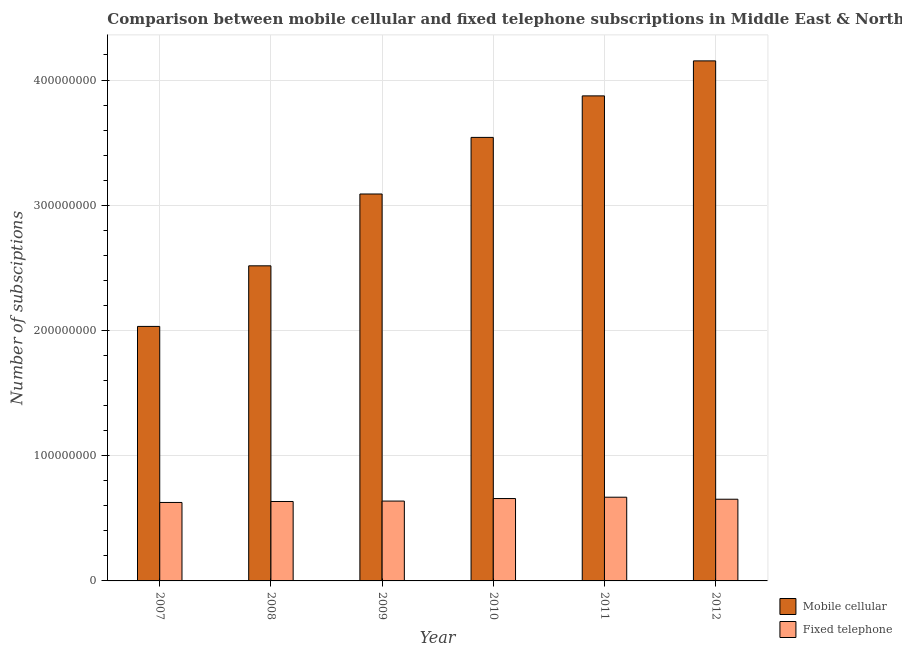Are the number of bars per tick equal to the number of legend labels?
Your response must be concise. Yes. Are the number of bars on each tick of the X-axis equal?
Your answer should be compact. Yes. How many bars are there on the 6th tick from the right?
Give a very brief answer. 2. What is the label of the 1st group of bars from the left?
Your answer should be very brief. 2007. What is the number of mobile cellular subscriptions in 2009?
Your answer should be compact. 3.09e+08. Across all years, what is the maximum number of mobile cellular subscriptions?
Offer a terse response. 4.15e+08. Across all years, what is the minimum number of fixed telephone subscriptions?
Make the answer very short. 6.27e+07. In which year was the number of fixed telephone subscriptions minimum?
Provide a succinct answer. 2007. What is the total number of fixed telephone subscriptions in the graph?
Offer a very short reply. 3.88e+08. What is the difference between the number of mobile cellular subscriptions in 2009 and that in 2010?
Your answer should be compact. -4.52e+07. What is the difference between the number of fixed telephone subscriptions in 2010 and the number of mobile cellular subscriptions in 2009?
Offer a terse response. 2.02e+06. What is the average number of fixed telephone subscriptions per year?
Ensure brevity in your answer.  6.46e+07. What is the ratio of the number of fixed telephone subscriptions in 2008 to that in 2011?
Offer a terse response. 0.95. Is the number of mobile cellular subscriptions in 2007 less than that in 2008?
Provide a succinct answer. Yes. What is the difference between the highest and the second highest number of mobile cellular subscriptions?
Your answer should be very brief. 2.80e+07. What is the difference between the highest and the lowest number of mobile cellular subscriptions?
Provide a succinct answer. 2.12e+08. Is the sum of the number of fixed telephone subscriptions in 2009 and 2012 greater than the maximum number of mobile cellular subscriptions across all years?
Your answer should be very brief. Yes. What does the 1st bar from the left in 2012 represents?
Give a very brief answer. Mobile cellular. What does the 2nd bar from the right in 2012 represents?
Your answer should be very brief. Mobile cellular. Does the graph contain any zero values?
Keep it short and to the point. No. Does the graph contain grids?
Keep it short and to the point. Yes. Where does the legend appear in the graph?
Offer a very short reply. Bottom right. How many legend labels are there?
Your answer should be compact. 2. What is the title of the graph?
Your response must be concise. Comparison between mobile cellular and fixed telephone subscriptions in Middle East & North Africa (all income levels). Does "Imports" appear as one of the legend labels in the graph?
Ensure brevity in your answer.  No. What is the label or title of the Y-axis?
Ensure brevity in your answer.  Number of subsciptions. What is the Number of subsciptions of Mobile cellular in 2007?
Ensure brevity in your answer.  2.03e+08. What is the Number of subsciptions in Fixed telephone in 2007?
Make the answer very short. 6.27e+07. What is the Number of subsciptions of Mobile cellular in 2008?
Your answer should be very brief. 2.52e+08. What is the Number of subsciptions in Fixed telephone in 2008?
Ensure brevity in your answer.  6.34e+07. What is the Number of subsciptions in Mobile cellular in 2009?
Offer a very short reply. 3.09e+08. What is the Number of subsciptions in Fixed telephone in 2009?
Offer a terse response. 6.38e+07. What is the Number of subsciptions of Mobile cellular in 2010?
Your answer should be compact. 3.54e+08. What is the Number of subsciptions in Fixed telephone in 2010?
Your answer should be very brief. 6.58e+07. What is the Number of subsciptions of Mobile cellular in 2011?
Your answer should be very brief. 3.87e+08. What is the Number of subsciptions in Fixed telephone in 2011?
Provide a short and direct response. 6.68e+07. What is the Number of subsciptions in Mobile cellular in 2012?
Give a very brief answer. 4.15e+08. What is the Number of subsciptions in Fixed telephone in 2012?
Ensure brevity in your answer.  6.52e+07. Across all years, what is the maximum Number of subsciptions of Mobile cellular?
Offer a very short reply. 4.15e+08. Across all years, what is the maximum Number of subsciptions of Fixed telephone?
Your answer should be very brief. 6.68e+07. Across all years, what is the minimum Number of subsciptions in Mobile cellular?
Offer a very short reply. 2.03e+08. Across all years, what is the minimum Number of subsciptions in Fixed telephone?
Offer a terse response. 6.27e+07. What is the total Number of subsciptions of Mobile cellular in the graph?
Offer a terse response. 1.92e+09. What is the total Number of subsciptions of Fixed telephone in the graph?
Ensure brevity in your answer.  3.88e+08. What is the difference between the Number of subsciptions of Mobile cellular in 2007 and that in 2008?
Offer a terse response. -4.84e+07. What is the difference between the Number of subsciptions of Fixed telephone in 2007 and that in 2008?
Offer a terse response. -7.72e+05. What is the difference between the Number of subsciptions of Mobile cellular in 2007 and that in 2009?
Offer a very short reply. -1.06e+08. What is the difference between the Number of subsciptions of Fixed telephone in 2007 and that in 2009?
Your answer should be compact. -1.11e+06. What is the difference between the Number of subsciptions of Mobile cellular in 2007 and that in 2010?
Keep it short and to the point. -1.51e+08. What is the difference between the Number of subsciptions in Fixed telephone in 2007 and that in 2010?
Your answer should be very brief. -3.13e+06. What is the difference between the Number of subsciptions in Mobile cellular in 2007 and that in 2011?
Offer a terse response. -1.84e+08. What is the difference between the Number of subsciptions of Fixed telephone in 2007 and that in 2011?
Offer a terse response. -4.19e+06. What is the difference between the Number of subsciptions of Mobile cellular in 2007 and that in 2012?
Give a very brief answer. -2.12e+08. What is the difference between the Number of subsciptions in Fixed telephone in 2007 and that in 2012?
Your response must be concise. -2.59e+06. What is the difference between the Number of subsciptions in Mobile cellular in 2008 and that in 2009?
Give a very brief answer. -5.74e+07. What is the difference between the Number of subsciptions in Fixed telephone in 2008 and that in 2009?
Provide a succinct answer. -3.36e+05. What is the difference between the Number of subsciptions of Mobile cellular in 2008 and that in 2010?
Offer a very short reply. -1.03e+08. What is the difference between the Number of subsciptions in Fixed telephone in 2008 and that in 2010?
Offer a very short reply. -2.35e+06. What is the difference between the Number of subsciptions in Mobile cellular in 2008 and that in 2011?
Provide a short and direct response. -1.36e+08. What is the difference between the Number of subsciptions in Fixed telephone in 2008 and that in 2011?
Offer a terse response. -3.42e+06. What is the difference between the Number of subsciptions in Mobile cellular in 2008 and that in 2012?
Offer a terse response. -1.64e+08. What is the difference between the Number of subsciptions of Fixed telephone in 2008 and that in 2012?
Your answer should be very brief. -1.81e+06. What is the difference between the Number of subsciptions of Mobile cellular in 2009 and that in 2010?
Your answer should be compact. -4.52e+07. What is the difference between the Number of subsciptions of Fixed telephone in 2009 and that in 2010?
Provide a short and direct response. -2.02e+06. What is the difference between the Number of subsciptions of Mobile cellular in 2009 and that in 2011?
Keep it short and to the point. -7.84e+07. What is the difference between the Number of subsciptions of Fixed telephone in 2009 and that in 2011?
Your answer should be very brief. -3.08e+06. What is the difference between the Number of subsciptions of Mobile cellular in 2009 and that in 2012?
Your response must be concise. -1.06e+08. What is the difference between the Number of subsciptions of Fixed telephone in 2009 and that in 2012?
Ensure brevity in your answer.  -1.48e+06. What is the difference between the Number of subsciptions in Mobile cellular in 2010 and that in 2011?
Your answer should be compact. -3.32e+07. What is the difference between the Number of subsciptions of Fixed telephone in 2010 and that in 2011?
Ensure brevity in your answer.  -1.06e+06. What is the difference between the Number of subsciptions in Mobile cellular in 2010 and that in 2012?
Provide a short and direct response. -6.11e+07. What is the difference between the Number of subsciptions of Fixed telephone in 2010 and that in 2012?
Ensure brevity in your answer.  5.40e+05. What is the difference between the Number of subsciptions of Mobile cellular in 2011 and that in 2012?
Make the answer very short. -2.80e+07. What is the difference between the Number of subsciptions in Fixed telephone in 2011 and that in 2012?
Provide a short and direct response. 1.60e+06. What is the difference between the Number of subsciptions of Mobile cellular in 2007 and the Number of subsciptions of Fixed telephone in 2008?
Your response must be concise. 1.40e+08. What is the difference between the Number of subsciptions of Mobile cellular in 2007 and the Number of subsciptions of Fixed telephone in 2009?
Give a very brief answer. 1.39e+08. What is the difference between the Number of subsciptions of Mobile cellular in 2007 and the Number of subsciptions of Fixed telephone in 2010?
Provide a short and direct response. 1.37e+08. What is the difference between the Number of subsciptions of Mobile cellular in 2007 and the Number of subsciptions of Fixed telephone in 2011?
Offer a terse response. 1.36e+08. What is the difference between the Number of subsciptions in Mobile cellular in 2007 and the Number of subsciptions in Fixed telephone in 2012?
Keep it short and to the point. 1.38e+08. What is the difference between the Number of subsciptions of Mobile cellular in 2008 and the Number of subsciptions of Fixed telephone in 2009?
Give a very brief answer. 1.88e+08. What is the difference between the Number of subsciptions of Mobile cellular in 2008 and the Number of subsciptions of Fixed telephone in 2010?
Provide a succinct answer. 1.86e+08. What is the difference between the Number of subsciptions of Mobile cellular in 2008 and the Number of subsciptions of Fixed telephone in 2011?
Provide a succinct answer. 1.85e+08. What is the difference between the Number of subsciptions in Mobile cellular in 2008 and the Number of subsciptions in Fixed telephone in 2012?
Keep it short and to the point. 1.86e+08. What is the difference between the Number of subsciptions in Mobile cellular in 2009 and the Number of subsciptions in Fixed telephone in 2010?
Offer a terse response. 2.43e+08. What is the difference between the Number of subsciptions of Mobile cellular in 2009 and the Number of subsciptions of Fixed telephone in 2011?
Make the answer very short. 2.42e+08. What is the difference between the Number of subsciptions of Mobile cellular in 2009 and the Number of subsciptions of Fixed telephone in 2012?
Provide a short and direct response. 2.44e+08. What is the difference between the Number of subsciptions in Mobile cellular in 2010 and the Number of subsciptions in Fixed telephone in 2011?
Your answer should be very brief. 2.87e+08. What is the difference between the Number of subsciptions in Mobile cellular in 2010 and the Number of subsciptions in Fixed telephone in 2012?
Your answer should be compact. 2.89e+08. What is the difference between the Number of subsciptions of Mobile cellular in 2011 and the Number of subsciptions of Fixed telephone in 2012?
Ensure brevity in your answer.  3.22e+08. What is the average Number of subsciptions in Mobile cellular per year?
Your answer should be compact. 3.20e+08. What is the average Number of subsciptions in Fixed telephone per year?
Your answer should be very brief. 6.46e+07. In the year 2007, what is the difference between the Number of subsciptions in Mobile cellular and Number of subsciptions in Fixed telephone?
Provide a succinct answer. 1.41e+08. In the year 2008, what is the difference between the Number of subsciptions of Mobile cellular and Number of subsciptions of Fixed telephone?
Provide a succinct answer. 1.88e+08. In the year 2009, what is the difference between the Number of subsciptions of Mobile cellular and Number of subsciptions of Fixed telephone?
Keep it short and to the point. 2.45e+08. In the year 2010, what is the difference between the Number of subsciptions in Mobile cellular and Number of subsciptions in Fixed telephone?
Your answer should be compact. 2.88e+08. In the year 2011, what is the difference between the Number of subsciptions of Mobile cellular and Number of subsciptions of Fixed telephone?
Make the answer very short. 3.20e+08. In the year 2012, what is the difference between the Number of subsciptions in Mobile cellular and Number of subsciptions in Fixed telephone?
Provide a succinct answer. 3.50e+08. What is the ratio of the Number of subsciptions in Mobile cellular in 2007 to that in 2008?
Offer a very short reply. 0.81. What is the ratio of the Number of subsciptions of Mobile cellular in 2007 to that in 2009?
Provide a short and direct response. 0.66. What is the ratio of the Number of subsciptions of Fixed telephone in 2007 to that in 2009?
Ensure brevity in your answer.  0.98. What is the ratio of the Number of subsciptions in Mobile cellular in 2007 to that in 2010?
Offer a very short reply. 0.57. What is the ratio of the Number of subsciptions in Fixed telephone in 2007 to that in 2010?
Keep it short and to the point. 0.95. What is the ratio of the Number of subsciptions of Mobile cellular in 2007 to that in 2011?
Keep it short and to the point. 0.52. What is the ratio of the Number of subsciptions of Fixed telephone in 2007 to that in 2011?
Provide a succinct answer. 0.94. What is the ratio of the Number of subsciptions in Mobile cellular in 2007 to that in 2012?
Your answer should be very brief. 0.49. What is the ratio of the Number of subsciptions of Fixed telephone in 2007 to that in 2012?
Your response must be concise. 0.96. What is the ratio of the Number of subsciptions in Mobile cellular in 2008 to that in 2009?
Provide a short and direct response. 0.81. What is the ratio of the Number of subsciptions of Fixed telephone in 2008 to that in 2009?
Your answer should be very brief. 0.99. What is the ratio of the Number of subsciptions of Mobile cellular in 2008 to that in 2010?
Your answer should be very brief. 0.71. What is the ratio of the Number of subsciptions of Fixed telephone in 2008 to that in 2010?
Your answer should be compact. 0.96. What is the ratio of the Number of subsciptions in Mobile cellular in 2008 to that in 2011?
Your response must be concise. 0.65. What is the ratio of the Number of subsciptions of Fixed telephone in 2008 to that in 2011?
Give a very brief answer. 0.95. What is the ratio of the Number of subsciptions in Mobile cellular in 2008 to that in 2012?
Your response must be concise. 0.61. What is the ratio of the Number of subsciptions of Fixed telephone in 2008 to that in 2012?
Provide a short and direct response. 0.97. What is the ratio of the Number of subsciptions in Mobile cellular in 2009 to that in 2010?
Give a very brief answer. 0.87. What is the ratio of the Number of subsciptions of Fixed telephone in 2009 to that in 2010?
Provide a succinct answer. 0.97. What is the ratio of the Number of subsciptions of Mobile cellular in 2009 to that in 2011?
Your response must be concise. 0.8. What is the ratio of the Number of subsciptions in Fixed telephone in 2009 to that in 2011?
Provide a short and direct response. 0.95. What is the ratio of the Number of subsciptions in Mobile cellular in 2009 to that in 2012?
Keep it short and to the point. 0.74. What is the ratio of the Number of subsciptions in Fixed telephone in 2009 to that in 2012?
Your answer should be very brief. 0.98. What is the ratio of the Number of subsciptions in Mobile cellular in 2010 to that in 2011?
Offer a terse response. 0.91. What is the ratio of the Number of subsciptions of Fixed telephone in 2010 to that in 2011?
Give a very brief answer. 0.98. What is the ratio of the Number of subsciptions in Mobile cellular in 2010 to that in 2012?
Ensure brevity in your answer.  0.85. What is the ratio of the Number of subsciptions of Fixed telephone in 2010 to that in 2012?
Offer a very short reply. 1.01. What is the ratio of the Number of subsciptions in Mobile cellular in 2011 to that in 2012?
Give a very brief answer. 0.93. What is the ratio of the Number of subsciptions of Fixed telephone in 2011 to that in 2012?
Your response must be concise. 1.02. What is the difference between the highest and the second highest Number of subsciptions of Mobile cellular?
Offer a terse response. 2.80e+07. What is the difference between the highest and the second highest Number of subsciptions of Fixed telephone?
Make the answer very short. 1.06e+06. What is the difference between the highest and the lowest Number of subsciptions of Mobile cellular?
Your response must be concise. 2.12e+08. What is the difference between the highest and the lowest Number of subsciptions of Fixed telephone?
Keep it short and to the point. 4.19e+06. 